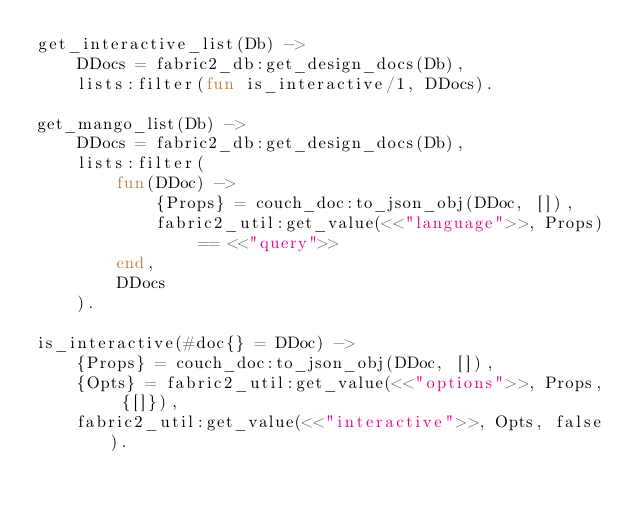<code> <loc_0><loc_0><loc_500><loc_500><_Erlang_>get_interactive_list(Db) ->
    DDocs = fabric2_db:get_design_docs(Db),
    lists:filter(fun is_interactive/1, DDocs).

get_mango_list(Db) ->
    DDocs = fabric2_db:get_design_docs(Db),
    lists:filter(
        fun(DDoc) ->
            {Props} = couch_doc:to_json_obj(DDoc, []),
            fabric2_util:get_value(<<"language">>, Props) == <<"query">>
        end,
        DDocs
    ).

is_interactive(#doc{} = DDoc) ->
    {Props} = couch_doc:to_json_obj(DDoc, []),
    {Opts} = fabric2_util:get_value(<<"options">>, Props, {[]}),
    fabric2_util:get_value(<<"interactive">>, Opts, false).
</code> 